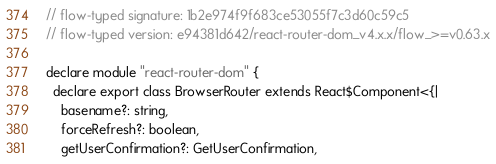<code> <loc_0><loc_0><loc_500><loc_500><_JavaScript_>// flow-typed signature: 1b2e974f9f683ce53055f7c3d60c59c5
// flow-typed version: e94381d642/react-router-dom_v4.x.x/flow_>=v0.63.x

declare module "react-router-dom" {
  declare export class BrowserRouter extends React$Component<{|
    basename?: string,
    forceRefresh?: boolean,
    getUserConfirmation?: GetUserConfirmation,</code> 